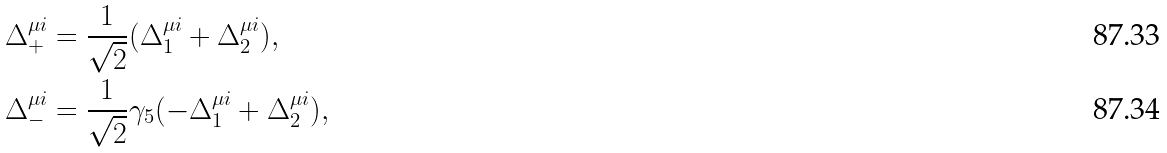Convert formula to latex. <formula><loc_0><loc_0><loc_500><loc_500>\Delta _ { + } ^ { \mu i } & = \frac { 1 } { \sqrt { 2 } } ( \Delta _ { 1 } ^ { \mu i } + \Delta _ { 2 } ^ { \mu i } ) , \\ \Delta _ { - } ^ { \mu i } & = \frac { 1 } { \sqrt { 2 } } \gamma _ { 5 } ( - \Delta _ { 1 } ^ { \mu i } + \Delta _ { 2 } ^ { \mu i } ) ,</formula> 